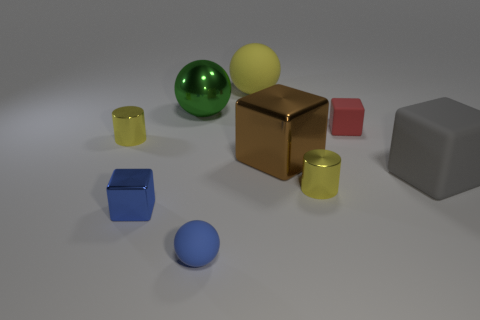Subtract all matte spheres. How many spheres are left? 1 Add 1 gray shiny things. How many objects exist? 10 Subtract 2 cubes. How many cubes are left? 2 Subtract all blue balls. How many balls are left? 2 Subtract all blocks. How many objects are left? 5 Subtract all green metallic things. Subtract all brown things. How many objects are left? 7 Add 3 gray blocks. How many gray blocks are left? 4 Add 1 big green things. How many big green things exist? 2 Subtract 0 green blocks. How many objects are left? 9 Subtract all cyan cubes. Subtract all red spheres. How many cubes are left? 4 